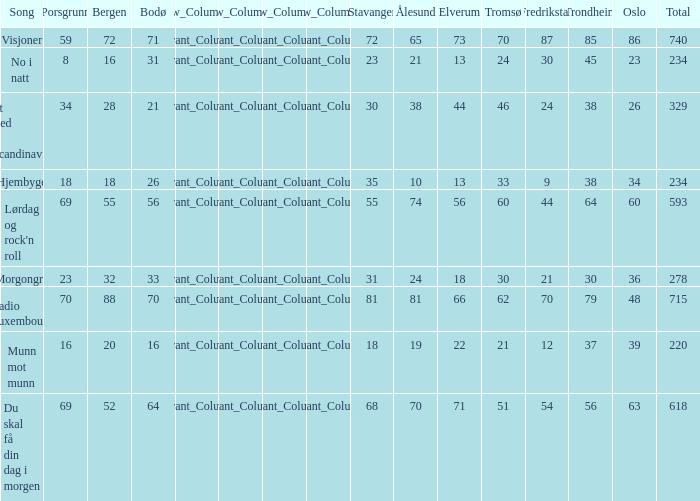How many elverum are tehre for et sted i scandinavia? 1.0. 